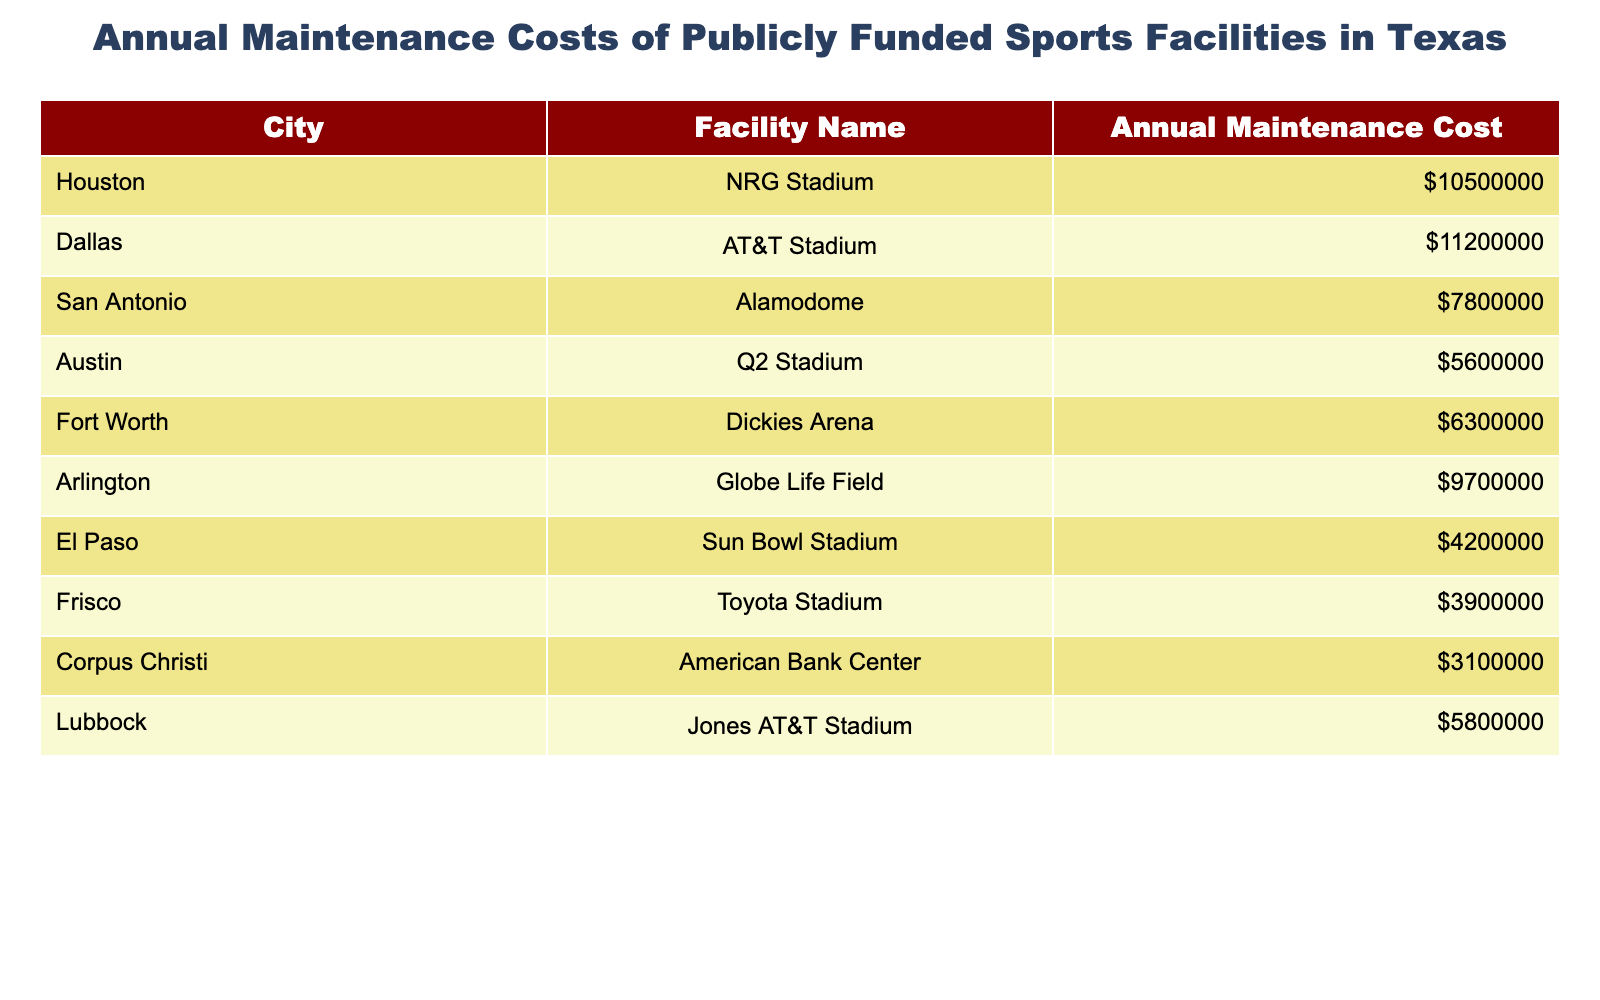What is the annual maintenance cost of AT&T Stadium? The table lists the annual maintenance cost for AT&T Stadium, which is $11,200,000.
Answer: $11,200,000 Which city has the highest annual maintenance cost for a sports facility? By comparing the values in the 'Annual Maintenance Cost' column, I can see that Houston's NRG Stadium has the highest cost at $10,500,000.
Answer: Houston What is the total annual maintenance cost of all the facilities listed? Adding up all the values from the 'Annual Maintenance Cost' column: $10,500,000 + $11,200,000 + $7,800,000 + $5,600,000 + $6,300,000 + $9,700,000 + $4,200,000 + $3,900,000 + $3,100,000 + $5,800,000 equals $68,300,000.
Answer: $68,300,000 Is the maintenance cost of the Alamodome more than $8 million? Looking at the cost listed for the Alamodome, which is $7,800,000, this is less than $8 million, so the statement is false.
Answer: No What is the difference in maintenance costs between Globe Life Field and Q2 Stadium? To find the difference, I subtract the cost of Q2 Stadium ($5,600,000) from Globe Life Field ($9,700,000): $9,700,000 - $5,600,000 = $4,100,000.
Answer: $4,100,000 What is the average annual maintenance cost of the facilities in Austin and Fort Worth? First, I find the individual costs: Q2 Stadium in Austin is $5,600,000, and Dickies Arena in Fort Worth is $6,300,000. Then, I calculate the average: ($5,600,000 + $6,300,000) / 2 = $5,950,000.
Answer: $5,950,000 How many facilities have maintenance costs less than $5 million? By examining the table, I see that the facilities with costs less than $5 million are the American Bank Center ($3,100,000), Toyota Stadium ($3,900,000), and Sun Bowl Stadium ($4,200,000), making three facilities in total.
Answer: 3 Are there more facilities with maintenance costs above or below $7 million? There are five facilities above $7 million (NRG Stadium, AT&T Stadium, Alamodome, Globe Life Field, and Dickies Arena) and five below $7 million (Q2 Stadium, Sun Bowl Stadium, Toyota Stadium, American Bank Center, and Jones AT&T Stadium) making it a tie.
Answer: It’s a tie What percentage of the total annual maintenance costs does AT&T Stadium represent? First, I find the total costs which is $68,300,000. Then, I calculate the percentage: ($11,200,000 / $68,300,000) * 100 = approximately 16.41%.
Answer: 16.41% 